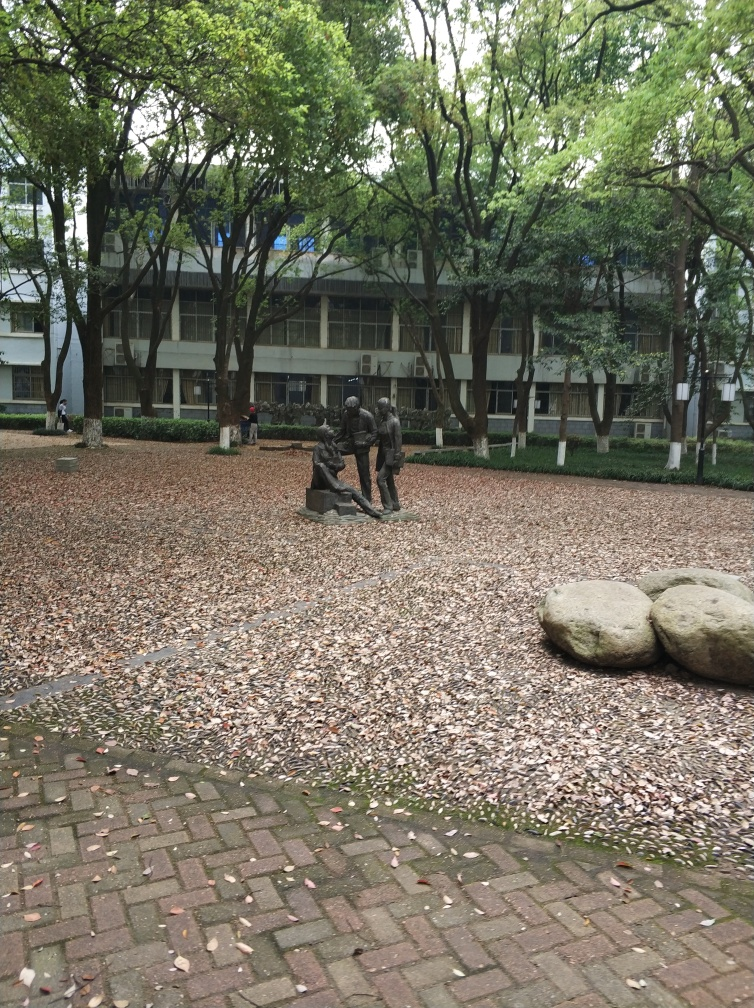Can you describe the setting and atmosphere of this place? The photograph captures a tranquil outdoor area, likely a park or campus with mature trees providing a lush green canopy. The weather appears overcast, suggesting a calm, serene atmosphere. The presence of a modern building in the background points to an urban environment. A statue of figures in the middle of the scene adds a focal point and cultural significance, possibly depicting a historical or social event. What can you tell me about the statues? The statues are of human figures engaged with one another, suggesting interaction and dynamic movement. They have a bronze finish, which is typical for outdoor sculptures, and their positioning implies a narrative or relationship among the characters. The art piece could commemorate an event, represent an allegory, or simply be a work for viewers to interpret as they will. 